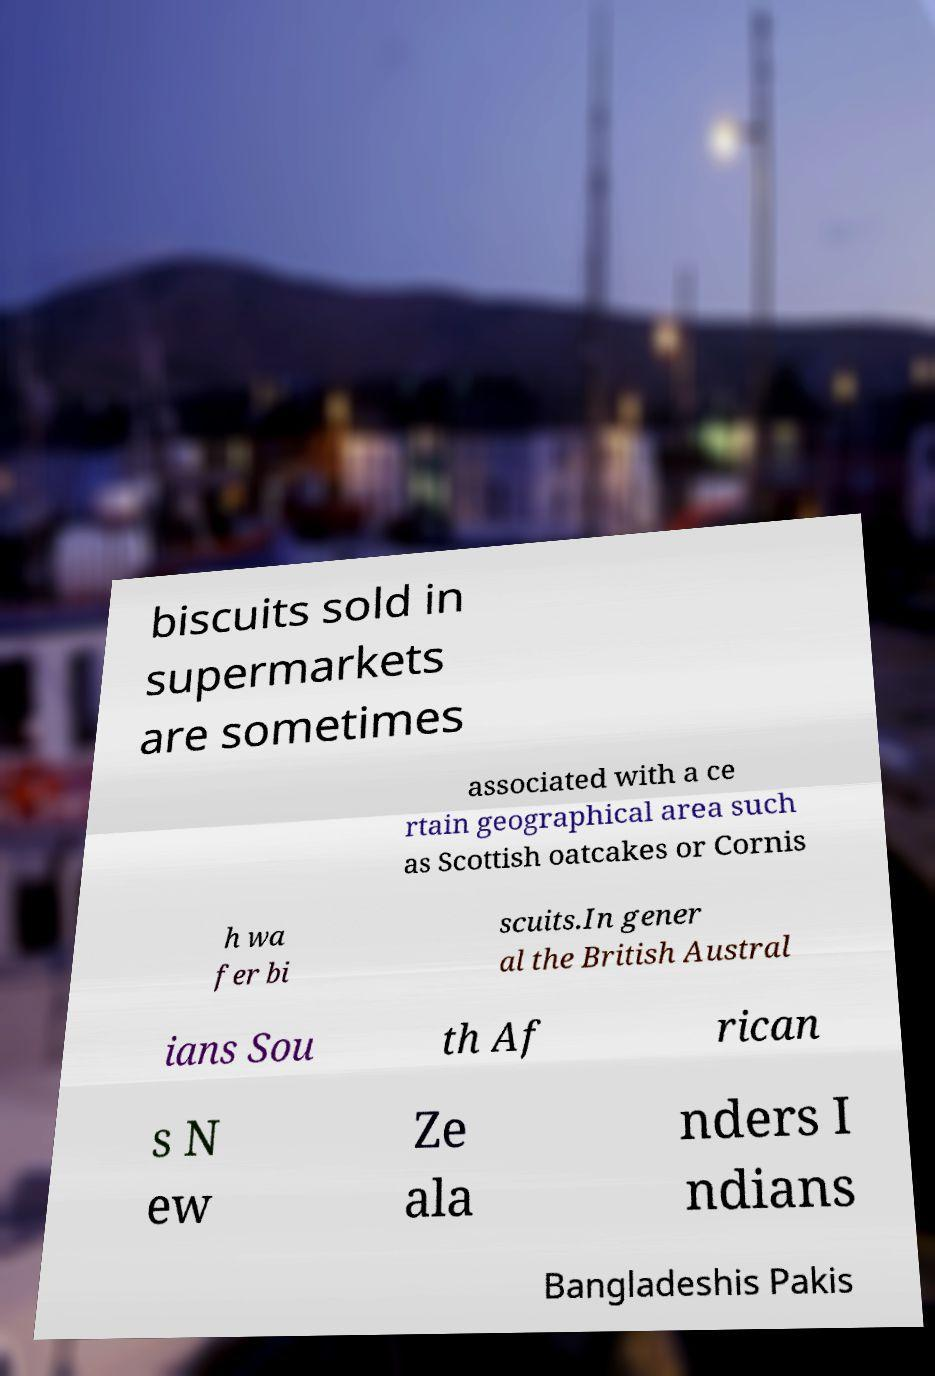Please identify and transcribe the text found in this image. biscuits sold in supermarkets are sometimes associated with a ce rtain geographical area such as Scottish oatcakes or Cornis h wa fer bi scuits.In gener al the British Austral ians Sou th Af rican s N ew Ze ala nders I ndians Bangladeshis Pakis 